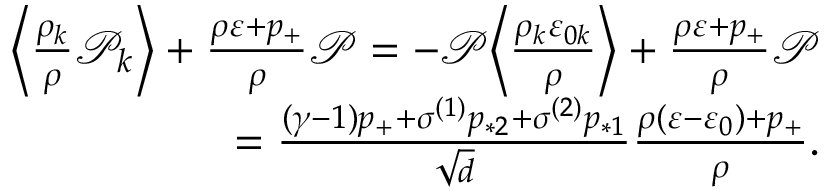<formula> <loc_0><loc_0><loc_500><loc_500>\begin{array} { r } { \left \langle \frac { \rho _ { k } } { \rho } \mathcal { P } _ { k } \right \rangle + \frac { \rho \varepsilon + p _ { + } } { \rho } \mathcal { P } = - \mathcal { P } \left \langle \frac { \rho _ { k } \varepsilon _ { 0 k } } { \rho } \right \rangle + \frac { \rho \varepsilon + p _ { + } } { \rho } \mathcal { P } } \\ { = \frac { ( \gamma - 1 ) p _ { + } + \sigma ^ { ( 1 ) } p _ { * 2 } + \sigma ^ { ( 2 ) } p _ { * 1 } } { \sqrt { d } } \frac { \rho ( \varepsilon - \varepsilon _ { 0 } ) + p _ { + } } { \rho } . } \end{array}</formula> 